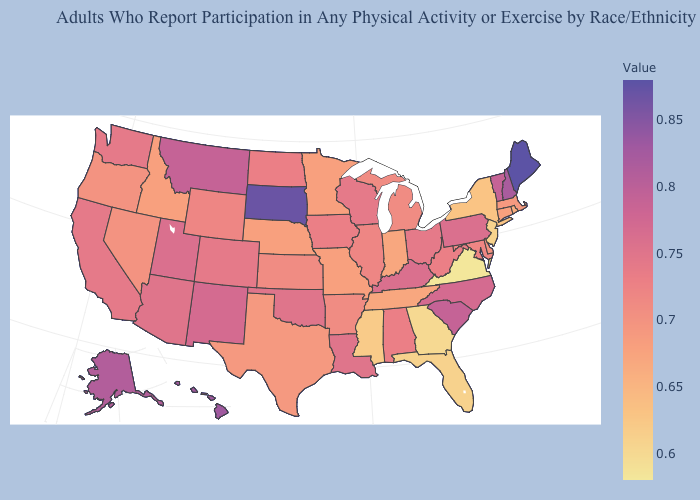Does Idaho have the lowest value in the West?
Write a very short answer. Yes. Does South Carolina have a lower value than New York?
Keep it brief. No. Does the map have missing data?
Quick response, please. No. Among the states that border New Mexico , which have the highest value?
Be succinct. Utah. Among the states that border Michigan , does Wisconsin have the lowest value?
Answer briefly. No. Does Maine have the highest value in the USA?
Write a very short answer. Yes. Among the states that border Colorado , which have the highest value?
Concise answer only. New Mexico. 